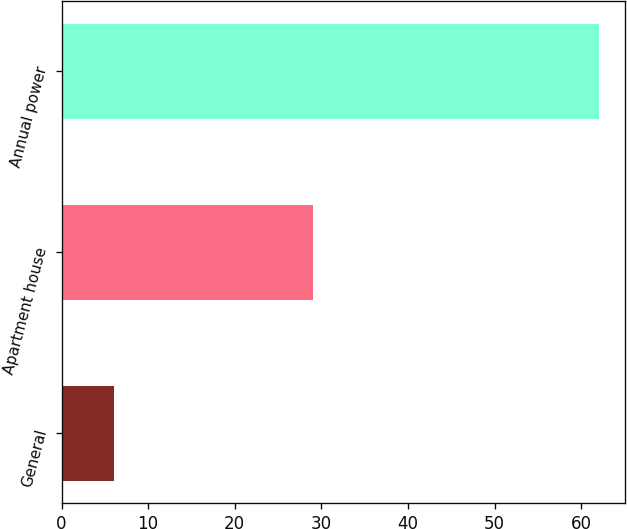Convert chart to OTSL. <chart><loc_0><loc_0><loc_500><loc_500><bar_chart><fcel>General<fcel>Apartment house<fcel>Annual power<nl><fcel>6<fcel>29<fcel>62<nl></chart> 